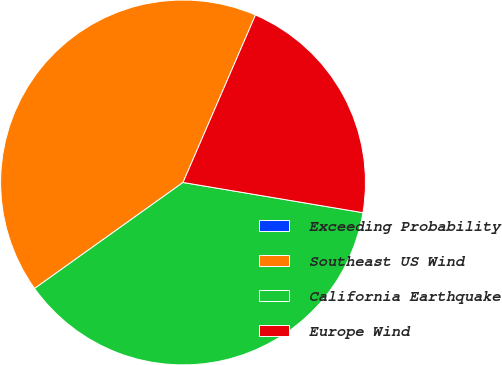Convert chart. <chart><loc_0><loc_0><loc_500><loc_500><pie_chart><fcel>Exceeding Probability<fcel>Southeast US Wind<fcel>California Earthquake<fcel>Europe Wind<nl><fcel>0.0%<fcel>41.37%<fcel>37.48%<fcel>21.15%<nl></chart> 